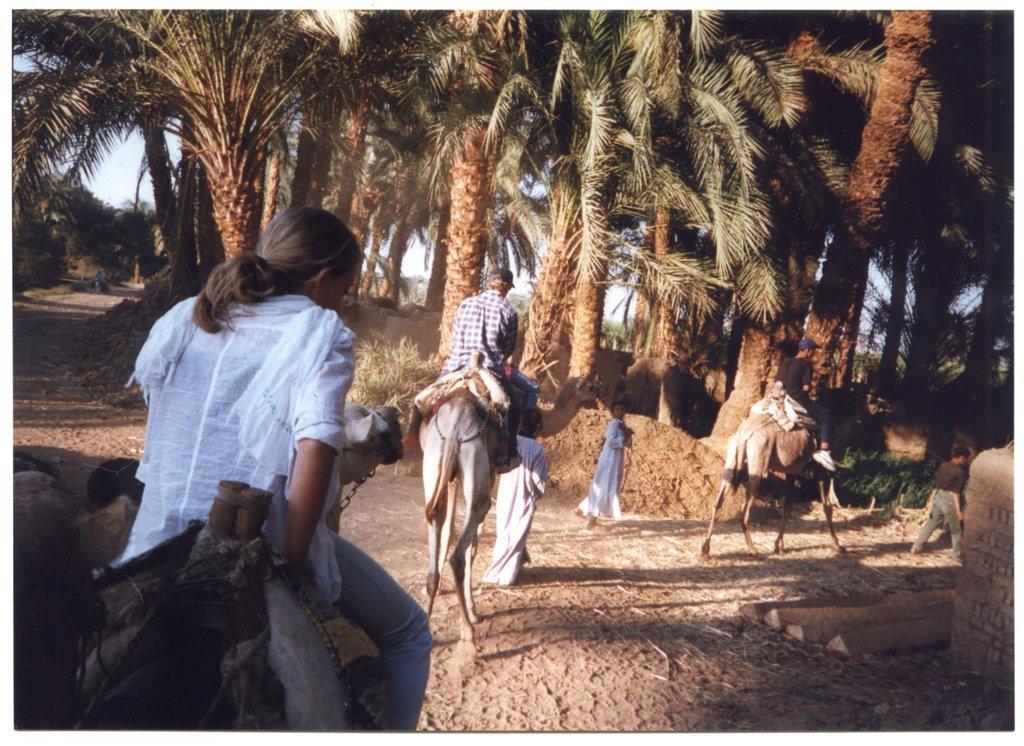Can you describe this image briefly? As we can see in the image there are few people here and there, camels, trees and sky. 